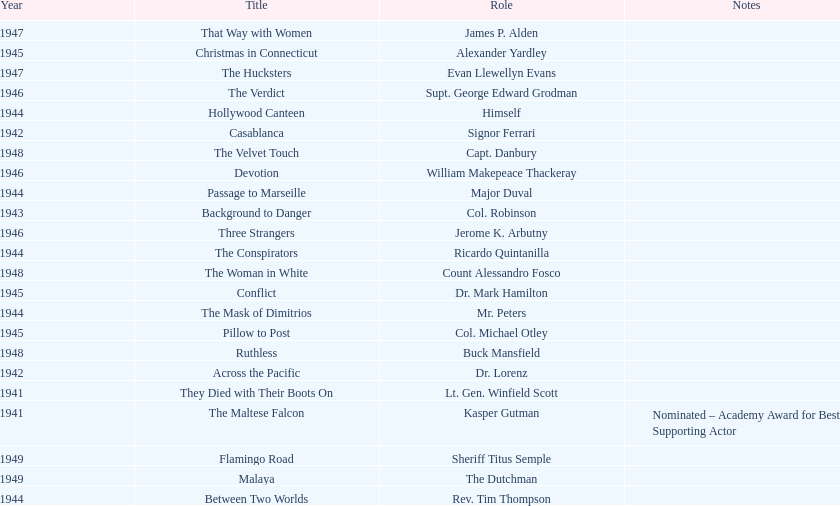Which movie did he get nominated for an oscar for? The Maltese Falcon. Could you help me parse every detail presented in this table? {'header': ['Year', 'Title', 'Role', 'Notes'], 'rows': [['1947', 'That Way with Women', 'James P. Alden', ''], ['1945', 'Christmas in Connecticut', 'Alexander Yardley', ''], ['1947', 'The Hucksters', 'Evan Llewellyn Evans', ''], ['1946', 'The Verdict', 'Supt. George Edward Grodman', ''], ['1944', 'Hollywood Canteen', 'Himself', ''], ['1942', 'Casablanca', 'Signor Ferrari', ''], ['1948', 'The Velvet Touch', 'Capt. Danbury', ''], ['1946', 'Devotion', 'William Makepeace Thackeray', ''], ['1944', 'Passage to Marseille', 'Major Duval', ''], ['1943', 'Background to Danger', 'Col. Robinson', ''], ['1946', 'Three Strangers', 'Jerome K. Arbutny', ''], ['1944', 'The Conspirators', 'Ricardo Quintanilla', ''], ['1948', 'The Woman in White', 'Count Alessandro Fosco', ''], ['1945', 'Conflict', 'Dr. Mark Hamilton', ''], ['1944', 'The Mask of Dimitrios', 'Mr. Peters', ''], ['1945', 'Pillow to Post', 'Col. Michael Otley', ''], ['1948', 'Ruthless', 'Buck Mansfield', ''], ['1942', 'Across the Pacific', 'Dr. Lorenz', ''], ['1941', 'They Died with Their Boots On', 'Lt. Gen. Winfield Scott', ''], ['1941', 'The Maltese Falcon', 'Kasper Gutman', 'Nominated – Academy Award for Best Supporting Actor'], ['1949', 'Flamingo Road', 'Sheriff Titus Semple', ''], ['1949', 'Malaya', 'The Dutchman', ''], ['1944', 'Between Two Worlds', 'Rev. Tim Thompson', '']]} 